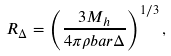Convert formula to latex. <formula><loc_0><loc_0><loc_500><loc_500>R _ { \Delta } = \left ( \frac { 3 M _ { h } } { 4 \pi \rho b a r \Delta } \right ) ^ { 1 / 3 } ,</formula> 